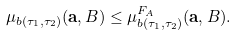Convert formula to latex. <formula><loc_0><loc_0><loc_500><loc_500>\mu _ { b ( \tau _ { 1 } , \tau _ { 2 } ) } ( \mathbf a , B ) \leq \mu ^ { F _ { A } } _ { b ( \tau _ { 1 } , \tau _ { 2 } ) } ( \mathbf a , B ) .</formula> 